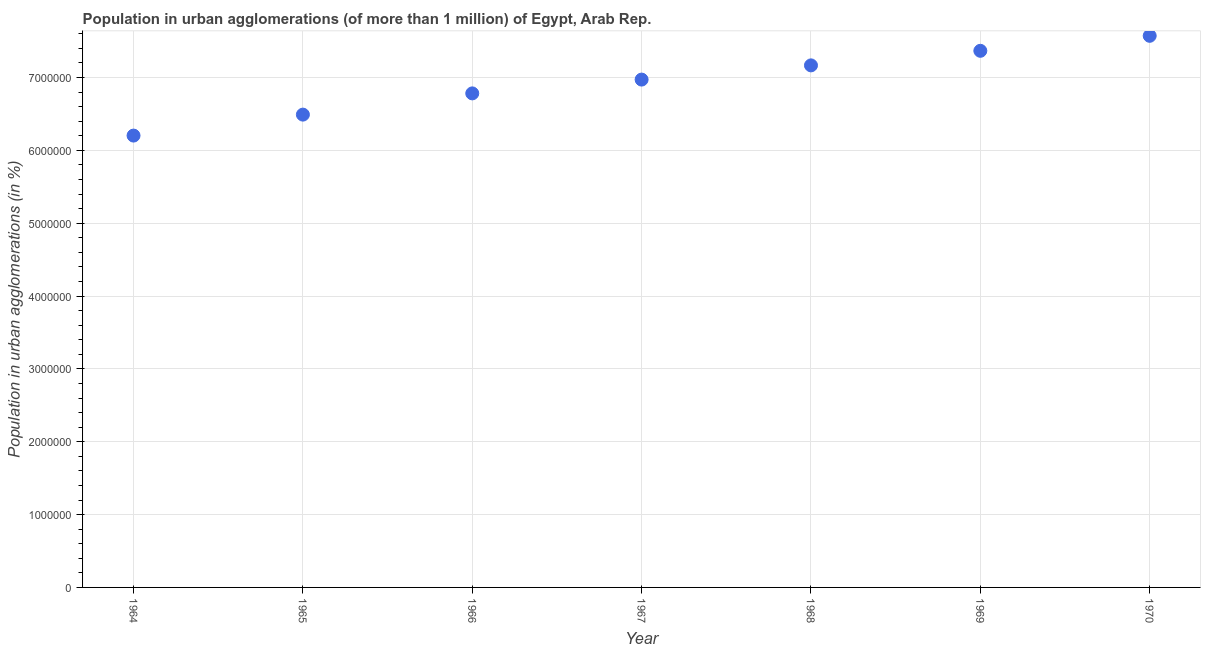What is the population in urban agglomerations in 1967?
Keep it short and to the point. 6.97e+06. Across all years, what is the maximum population in urban agglomerations?
Make the answer very short. 7.57e+06. Across all years, what is the minimum population in urban agglomerations?
Offer a very short reply. 6.20e+06. In which year was the population in urban agglomerations maximum?
Your answer should be very brief. 1970. In which year was the population in urban agglomerations minimum?
Make the answer very short. 1964. What is the sum of the population in urban agglomerations?
Offer a very short reply. 4.85e+07. What is the difference between the population in urban agglomerations in 1964 and 1969?
Your answer should be compact. -1.16e+06. What is the average population in urban agglomerations per year?
Make the answer very short. 6.94e+06. What is the median population in urban agglomerations?
Offer a very short reply. 6.97e+06. In how many years, is the population in urban agglomerations greater than 600000 %?
Provide a succinct answer. 7. Do a majority of the years between 1966 and 1965 (inclusive) have population in urban agglomerations greater than 6000000 %?
Provide a succinct answer. No. What is the ratio of the population in urban agglomerations in 1964 to that in 1968?
Your response must be concise. 0.87. Is the population in urban agglomerations in 1965 less than that in 1967?
Keep it short and to the point. Yes. Is the difference between the population in urban agglomerations in 1964 and 1970 greater than the difference between any two years?
Make the answer very short. Yes. What is the difference between the highest and the second highest population in urban agglomerations?
Provide a succinct answer. 2.06e+05. What is the difference between the highest and the lowest population in urban agglomerations?
Your response must be concise. 1.37e+06. How many dotlines are there?
Your response must be concise. 1. How many years are there in the graph?
Your answer should be compact. 7. Does the graph contain grids?
Offer a terse response. Yes. What is the title of the graph?
Your answer should be very brief. Population in urban agglomerations (of more than 1 million) of Egypt, Arab Rep. What is the label or title of the X-axis?
Offer a very short reply. Year. What is the label or title of the Y-axis?
Offer a very short reply. Population in urban agglomerations (in %). What is the Population in urban agglomerations (in %) in 1964?
Keep it short and to the point. 6.20e+06. What is the Population in urban agglomerations (in %) in 1965?
Give a very brief answer. 6.49e+06. What is the Population in urban agglomerations (in %) in 1966?
Make the answer very short. 6.78e+06. What is the Population in urban agglomerations (in %) in 1967?
Your answer should be compact. 6.97e+06. What is the Population in urban agglomerations (in %) in 1968?
Offer a very short reply. 7.17e+06. What is the Population in urban agglomerations (in %) in 1969?
Keep it short and to the point. 7.37e+06. What is the Population in urban agglomerations (in %) in 1970?
Keep it short and to the point. 7.57e+06. What is the difference between the Population in urban agglomerations (in %) in 1964 and 1965?
Keep it short and to the point. -2.88e+05. What is the difference between the Population in urban agglomerations (in %) in 1964 and 1966?
Offer a terse response. -5.79e+05. What is the difference between the Population in urban agglomerations (in %) in 1964 and 1967?
Offer a very short reply. -7.69e+05. What is the difference between the Population in urban agglomerations (in %) in 1964 and 1968?
Offer a very short reply. -9.64e+05. What is the difference between the Population in urban agglomerations (in %) in 1964 and 1969?
Keep it short and to the point. -1.16e+06. What is the difference between the Population in urban agglomerations (in %) in 1964 and 1970?
Provide a short and direct response. -1.37e+06. What is the difference between the Population in urban agglomerations (in %) in 1965 and 1966?
Your answer should be very brief. -2.91e+05. What is the difference between the Population in urban agglomerations (in %) in 1965 and 1967?
Make the answer very short. -4.81e+05. What is the difference between the Population in urban agglomerations (in %) in 1965 and 1968?
Provide a short and direct response. -6.76e+05. What is the difference between the Population in urban agglomerations (in %) in 1965 and 1969?
Give a very brief answer. -8.76e+05. What is the difference between the Population in urban agglomerations (in %) in 1965 and 1970?
Offer a very short reply. -1.08e+06. What is the difference between the Population in urban agglomerations (in %) in 1966 and 1967?
Provide a short and direct response. -1.89e+05. What is the difference between the Population in urban agglomerations (in %) in 1966 and 1968?
Offer a very short reply. -3.84e+05. What is the difference between the Population in urban agglomerations (in %) in 1966 and 1969?
Ensure brevity in your answer.  -5.84e+05. What is the difference between the Population in urban agglomerations (in %) in 1966 and 1970?
Make the answer very short. -7.90e+05. What is the difference between the Population in urban agglomerations (in %) in 1967 and 1968?
Make the answer very short. -1.95e+05. What is the difference between the Population in urban agglomerations (in %) in 1967 and 1969?
Offer a very short reply. -3.95e+05. What is the difference between the Population in urban agglomerations (in %) in 1967 and 1970?
Make the answer very short. -6.01e+05. What is the difference between the Population in urban agglomerations (in %) in 1968 and 1969?
Offer a very short reply. -2.00e+05. What is the difference between the Population in urban agglomerations (in %) in 1968 and 1970?
Keep it short and to the point. -4.06e+05. What is the difference between the Population in urban agglomerations (in %) in 1969 and 1970?
Provide a short and direct response. -2.06e+05. What is the ratio of the Population in urban agglomerations (in %) in 1964 to that in 1965?
Your answer should be compact. 0.96. What is the ratio of the Population in urban agglomerations (in %) in 1964 to that in 1966?
Your answer should be very brief. 0.92. What is the ratio of the Population in urban agglomerations (in %) in 1964 to that in 1967?
Offer a terse response. 0.89. What is the ratio of the Population in urban agglomerations (in %) in 1964 to that in 1968?
Keep it short and to the point. 0.87. What is the ratio of the Population in urban agglomerations (in %) in 1964 to that in 1969?
Make the answer very short. 0.84. What is the ratio of the Population in urban agglomerations (in %) in 1964 to that in 1970?
Your response must be concise. 0.82. What is the ratio of the Population in urban agglomerations (in %) in 1965 to that in 1968?
Your answer should be very brief. 0.91. What is the ratio of the Population in urban agglomerations (in %) in 1965 to that in 1969?
Provide a succinct answer. 0.88. What is the ratio of the Population in urban agglomerations (in %) in 1965 to that in 1970?
Your answer should be compact. 0.86. What is the ratio of the Population in urban agglomerations (in %) in 1966 to that in 1967?
Your answer should be very brief. 0.97. What is the ratio of the Population in urban agglomerations (in %) in 1966 to that in 1968?
Offer a very short reply. 0.95. What is the ratio of the Population in urban agglomerations (in %) in 1966 to that in 1969?
Your answer should be very brief. 0.92. What is the ratio of the Population in urban agglomerations (in %) in 1966 to that in 1970?
Ensure brevity in your answer.  0.9. What is the ratio of the Population in urban agglomerations (in %) in 1967 to that in 1969?
Make the answer very short. 0.95. What is the ratio of the Population in urban agglomerations (in %) in 1967 to that in 1970?
Your response must be concise. 0.92. What is the ratio of the Population in urban agglomerations (in %) in 1968 to that in 1969?
Provide a succinct answer. 0.97. What is the ratio of the Population in urban agglomerations (in %) in 1968 to that in 1970?
Your answer should be very brief. 0.95. 